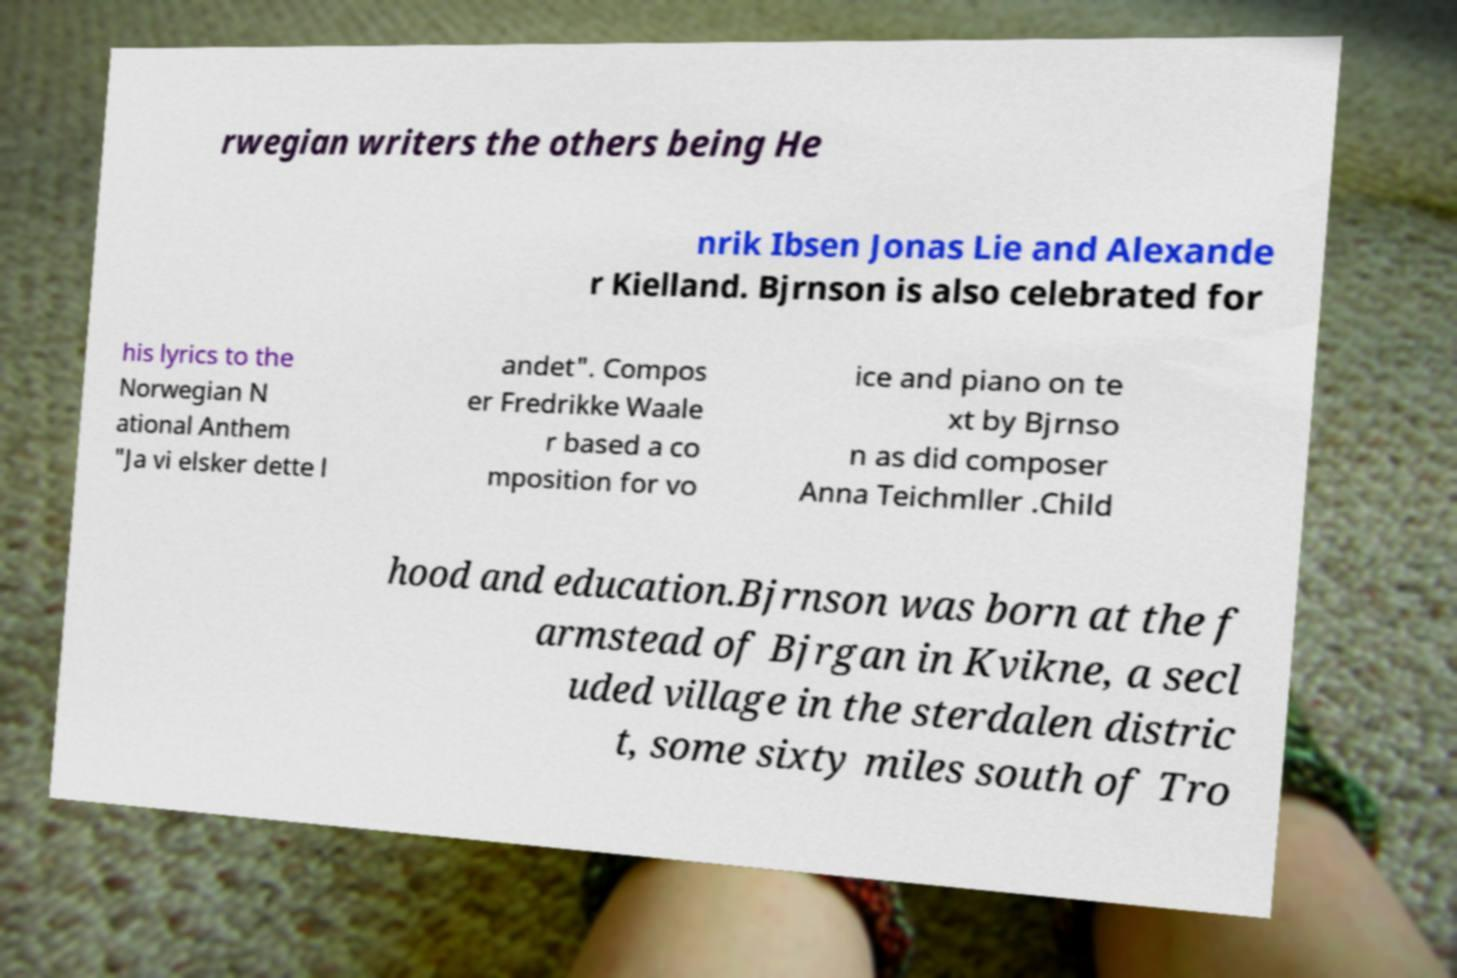There's text embedded in this image that I need extracted. Can you transcribe it verbatim? rwegian writers the others being He nrik Ibsen Jonas Lie and Alexande r Kielland. Bjrnson is also celebrated for his lyrics to the Norwegian N ational Anthem "Ja vi elsker dette l andet". Compos er Fredrikke Waale r based a co mposition for vo ice and piano on te xt by Bjrnso n as did composer Anna Teichmller .Child hood and education.Bjrnson was born at the f armstead of Bjrgan in Kvikne, a secl uded village in the sterdalen distric t, some sixty miles south of Tro 